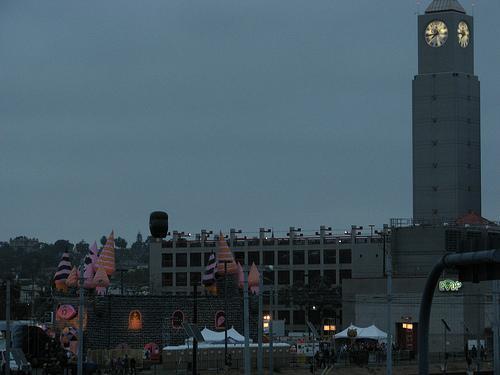How many clocks are shown?
Give a very brief answer. 2. How many flags are in the photo?
Give a very brief answer. 9. How many different kinds of flags are in the photo?
Give a very brief answer. 3. 